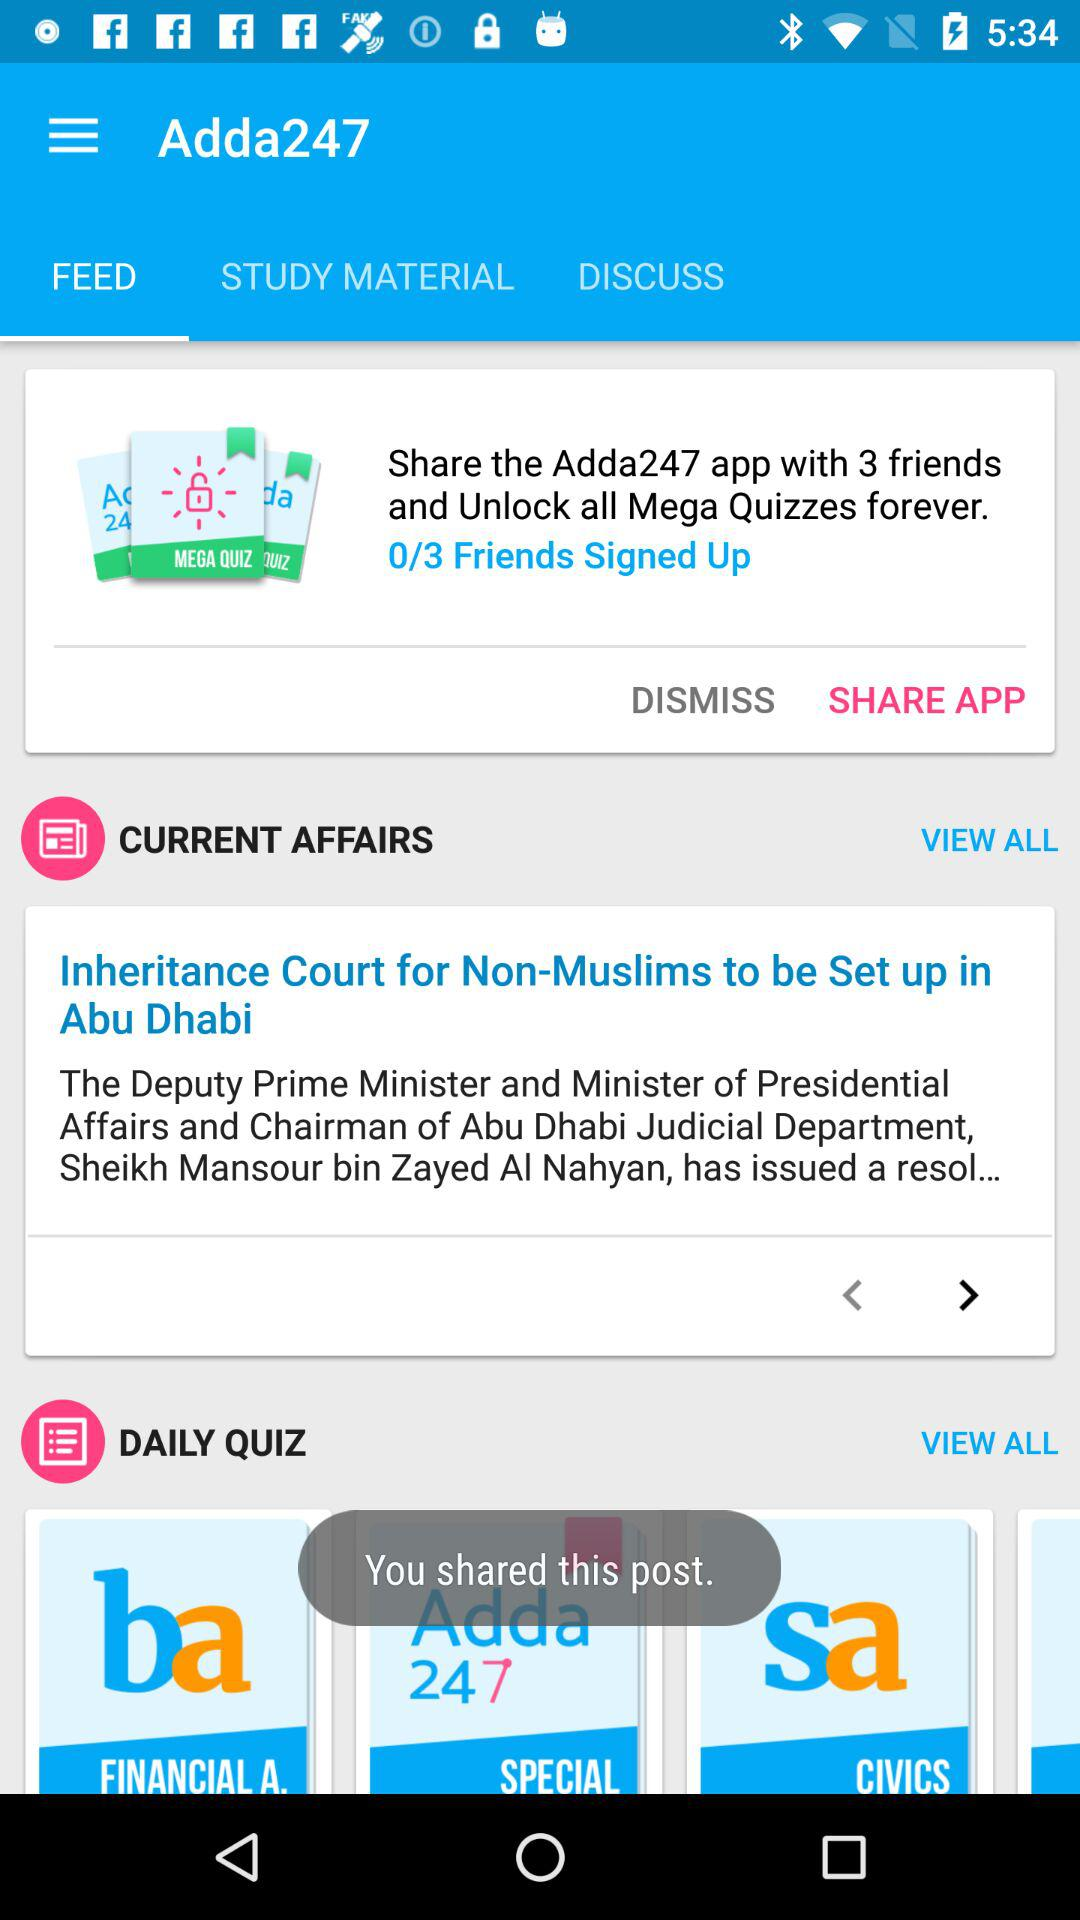How many more friends do I need to sign up to unlock all the mega quizzes?
Answer the question using a single word or phrase. 3 